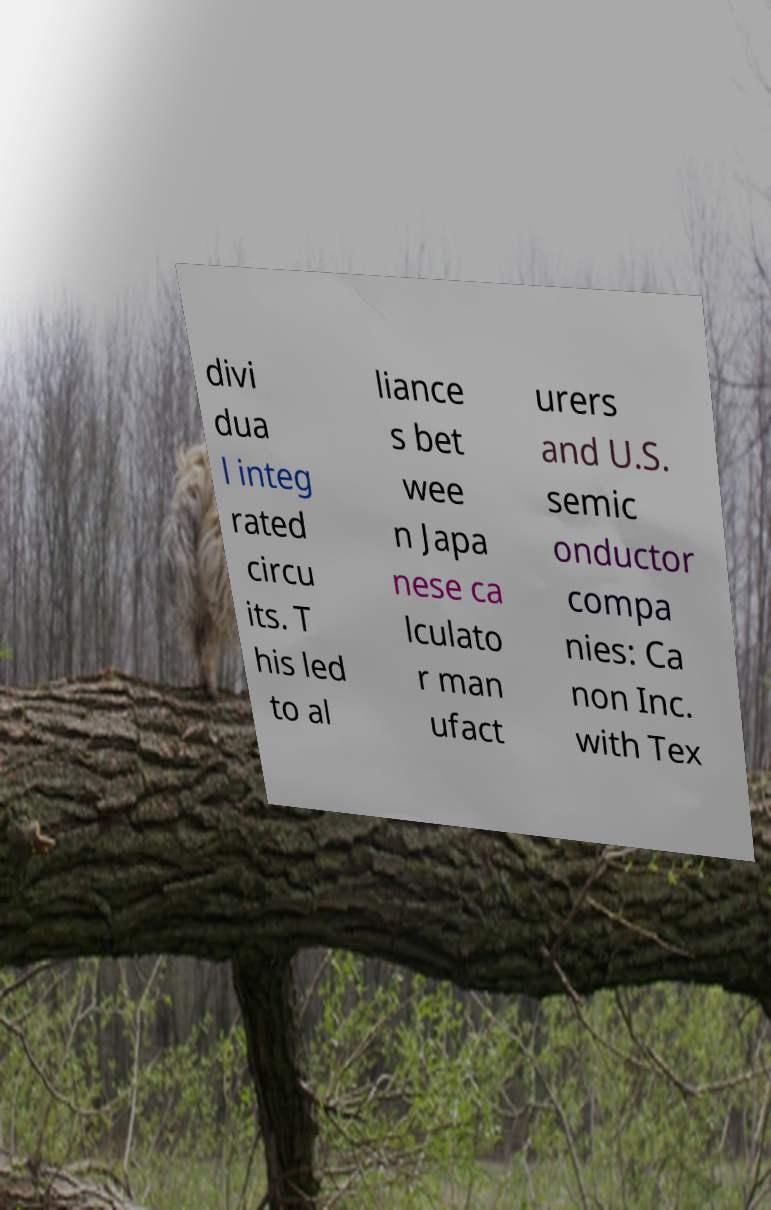Can you accurately transcribe the text from the provided image for me? divi dua l integ rated circu its. T his led to al liance s bet wee n Japa nese ca lculato r man ufact urers and U.S. semic onductor compa nies: Ca non Inc. with Tex 